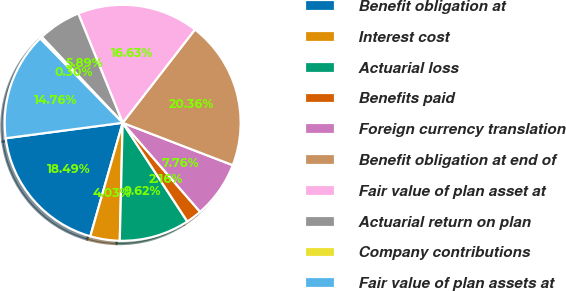<chart> <loc_0><loc_0><loc_500><loc_500><pie_chart><fcel>Benefit obligation at<fcel>Interest cost<fcel>Actuarial loss<fcel>Benefits paid<fcel>Foreign currency translation<fcel>Benefit obligation at end of<fcel>Fair value of plan asset at<fcel>Actuarial return on plan<fcel>Company contributions<fcel>Fair value of plan assets at<nl><fcel>18.49%<fcel>4.03%<fcel>9.62%<fcel>2.16%<fcel>7.76%<fcel>20.36%<fcel>16.63%<fcel>5.89%<fcel>0.3%<fcel>14.76%<nl></chart> 